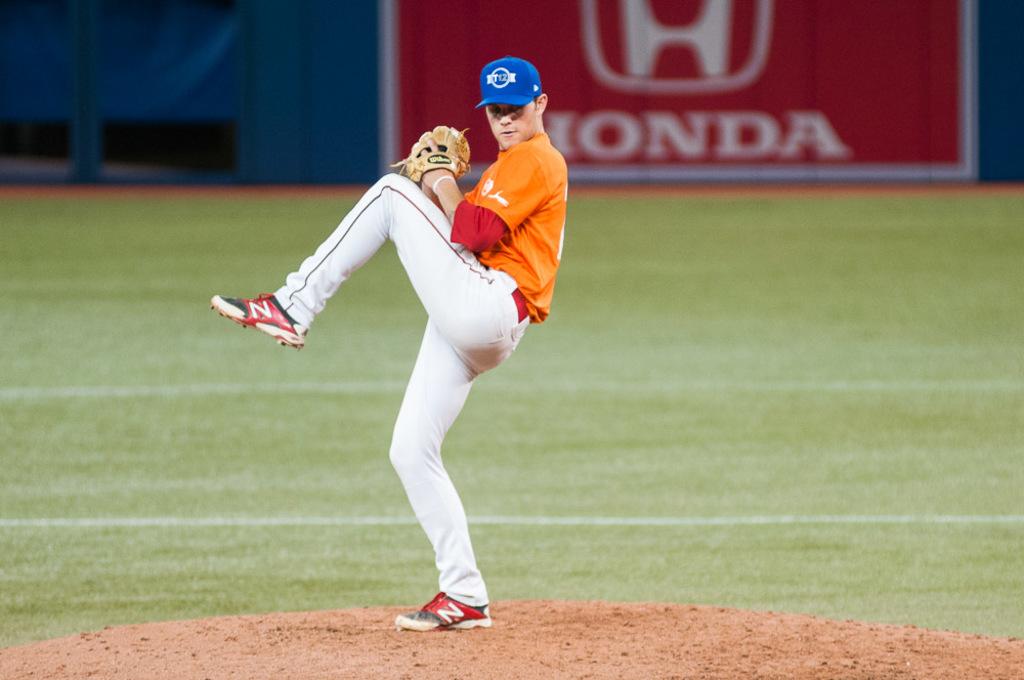What is the automobile brand in the background?
Your answer should be very brief. Honda. 